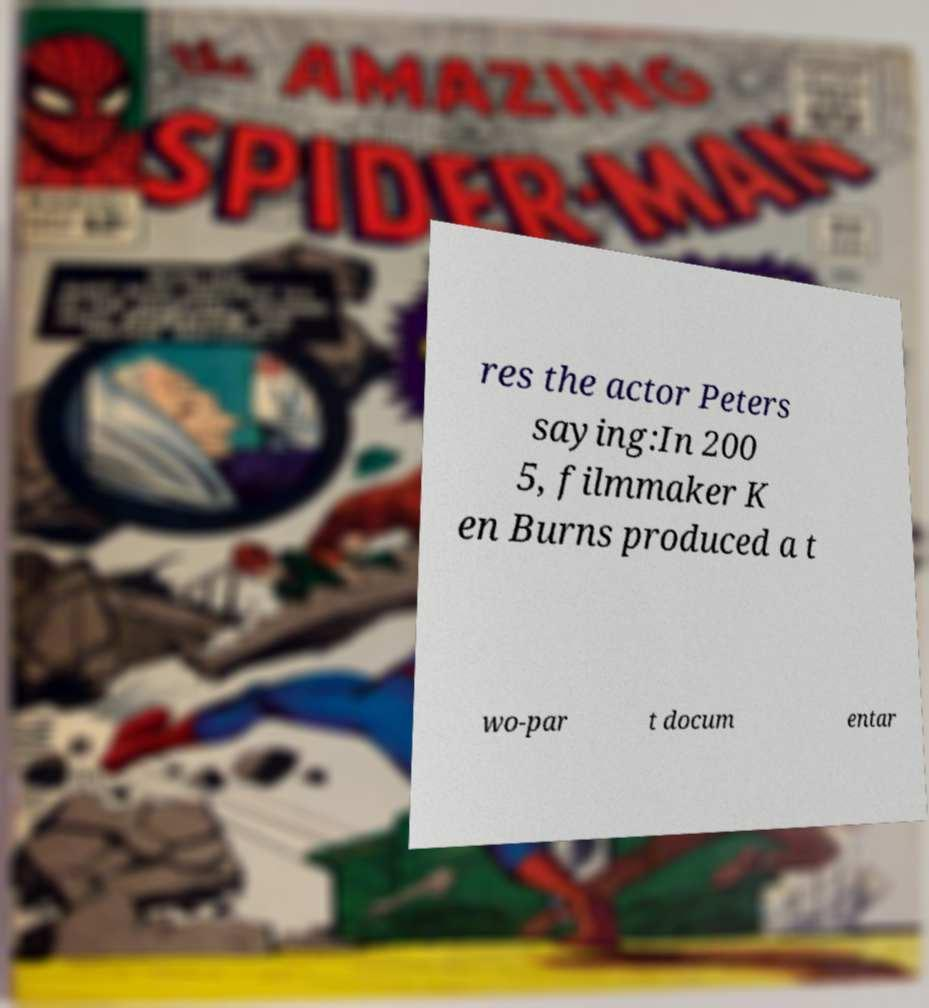For documentation purposes, I need the text within this image transcribed. Could you provide that? res the actor Peters saying:In 200 5, filmmaker K en Burns produced a t wo-par t docum entar 